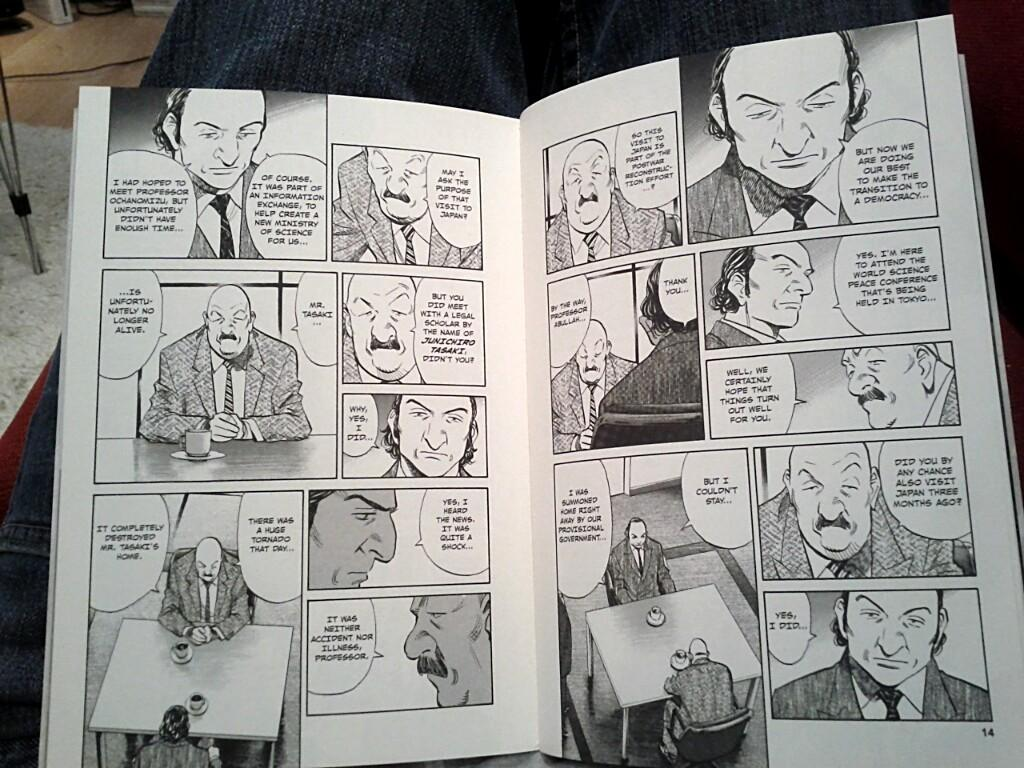What can be found on the pages of the book in the image? There are words and images of people on the papers of the book. Can you describe the background of the image? There are objects visible in the background of the image. What type of linen is being used to cover the objects in the background? There is no linen visible in the image; the objects in the background are not covered. 